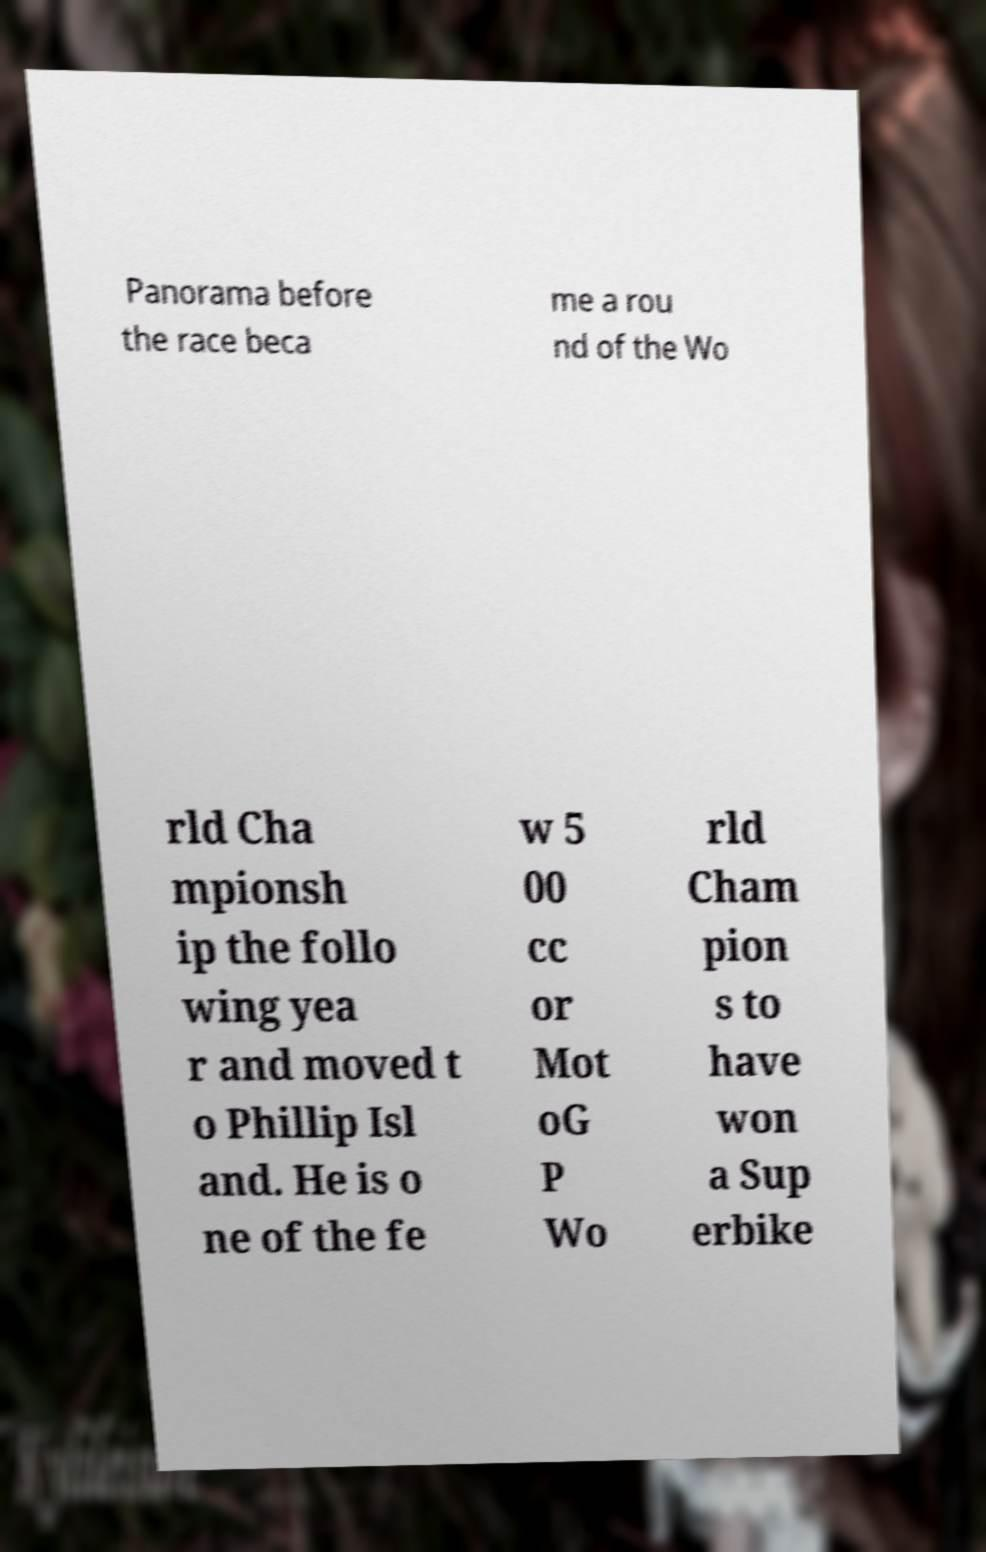Can you accurately transcribe the text from the provided image for me? Panorama before the race beca me a rou nd of the Wo rld Cha mpionsh ip the follo wing yea r and moved t o Phillip Isl and. He is o ne of the fe w 5 00 cc or Mot oG P Wo rld Cham pion s to have won a Sup erbike 